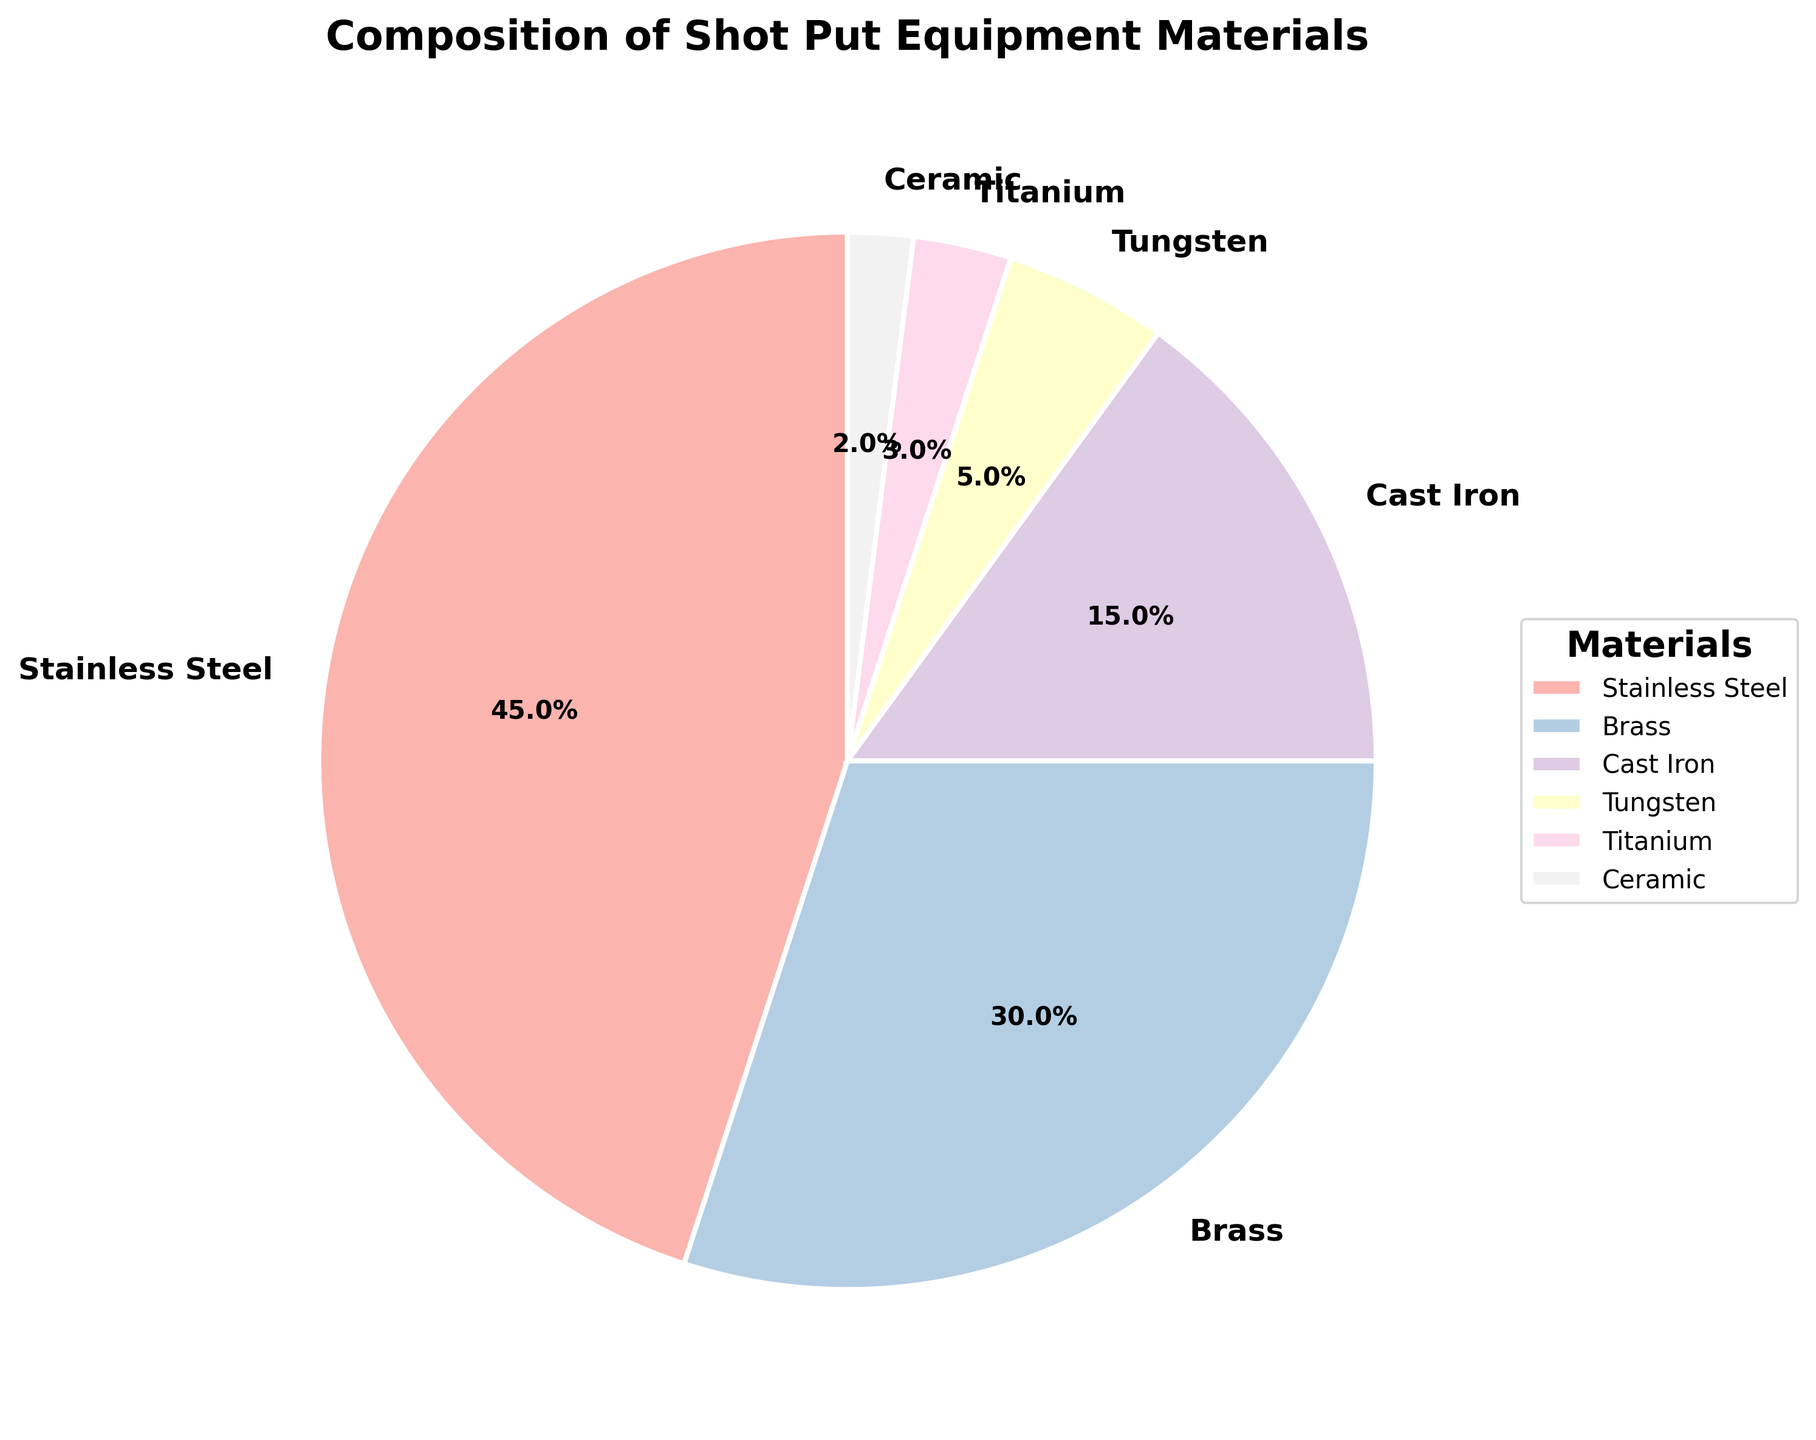What material comprises the largest portion of shot put equipment? The pie chart shows the percentage of each material. Stainless Steel occupies the largest portion at 45%.
Answer: Stainless Steel How much more percentage of shot put equipment is made of Stainless Steel compared to Titanium and Ceramic combined? Titanium makes up 3% and Ceramic makes up 2%. Their combined percentage is 3% + 2% = 5%. Stainless Steel, at 45%, exceeds this by 45% - 5% = 40%.
Answer: 40% Which material is used more, Brass or Cast Iron? The pie chart indicates that Brass constitutes 30%, while Cast Iron is 15%. Therefore, Brass is used more.
Answer: Brass What is the total percentage of shot put equipment made of materials other than Stainless Steel? Adding up the percentages of Brass, Cast Iron, Tungsten, Titanium, and Ceramic gives 30% + 15% + 5% + 3% + 2%, totaling 55%.
Answer: 55% Is Tungsten used more than Ceramics but less than Cast Iron? From the charts, Tungsten comprises 5%, Ceramics 2%, and Cast Iron 15%. Tungsten is indeed more than Ceramics (5% vs. 2%) but less than Cast Iron (5% vs. 15%).
Answer: Yes 